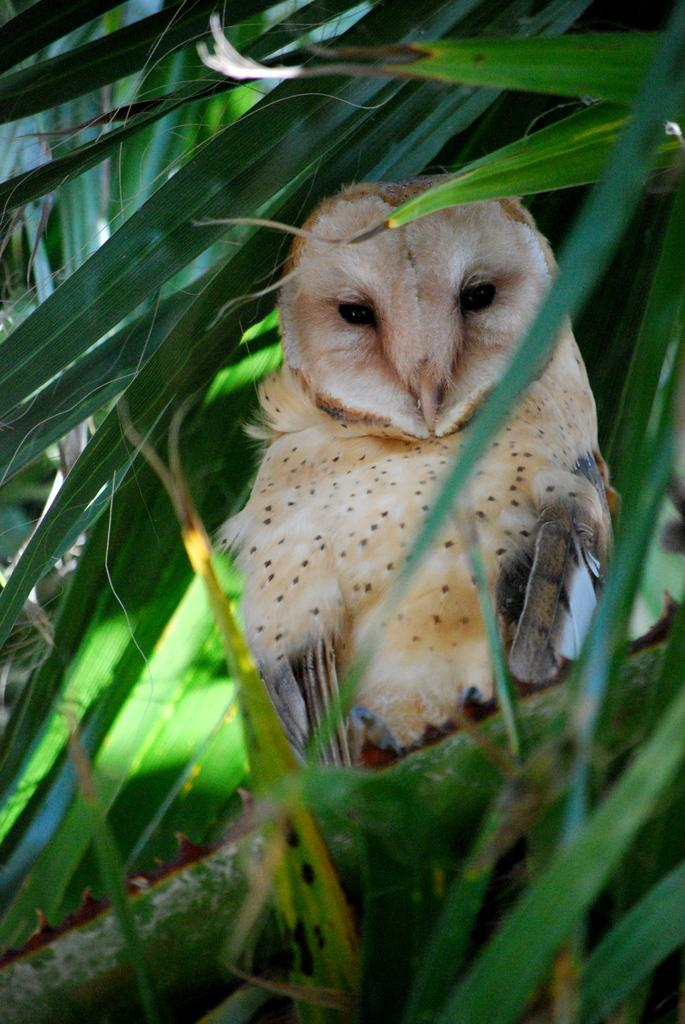What animal is in the image? There is an owl in the image. Where is the owl located? The owl is on a branch of a tree. What can be seen around the owl? There are leaves around the owl. What type of paper can be seen in the image? There is no paper present in the image; it features an owl on a tree branch surrounded by leaves. 